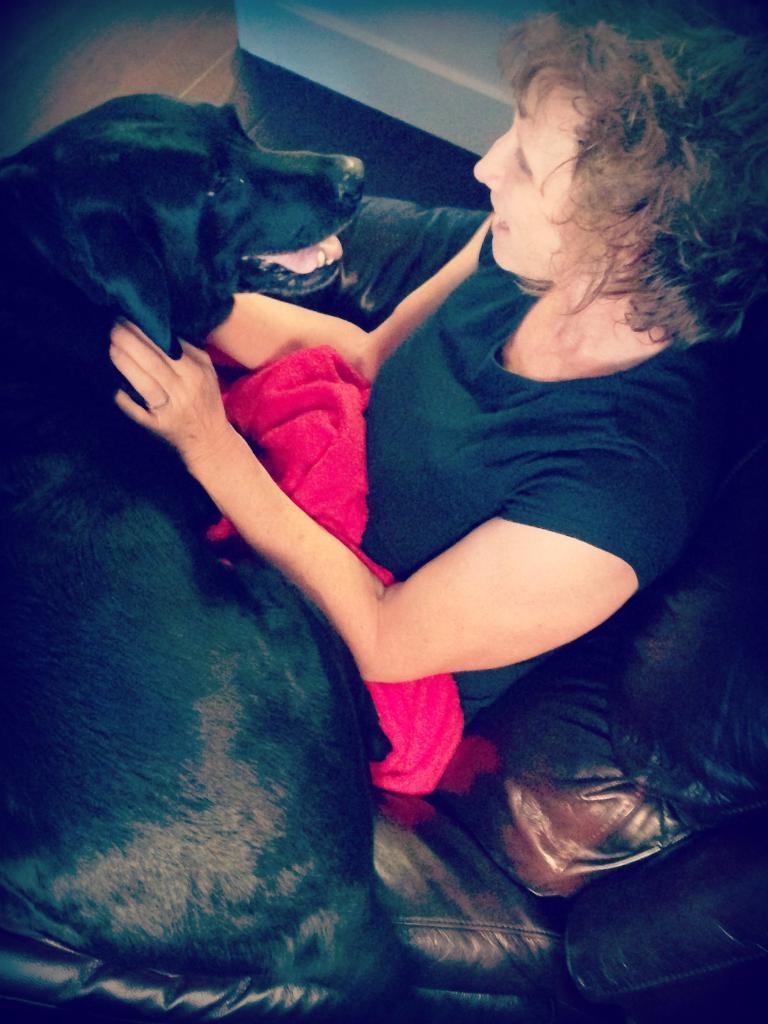Please provide a concise description of this image. In this image there is a lady sitting on a sofa and she is holding a black dog in her hands. And she is looking at the dogs face. 